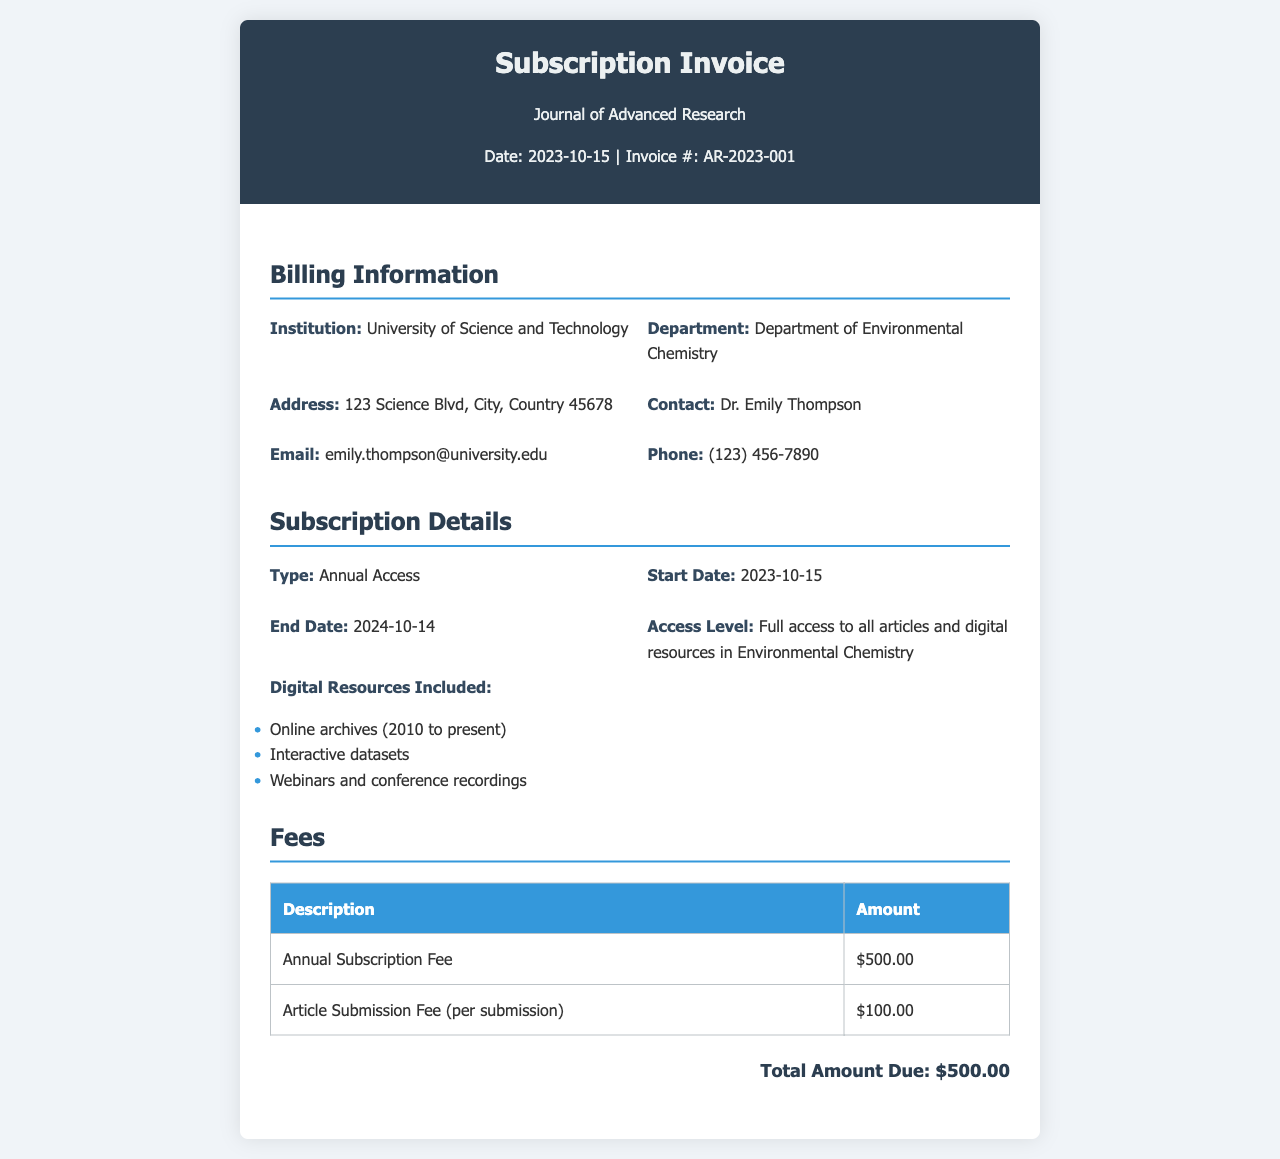What is the invoice date? The invoice date is specified in the header section of the document.
Answer: 2023-10-15 Who is the contact person listed on the invoice? The contact person is mentioned in the billing information section.
Answer: Dr. Emily Thompson What is the total amount due for the subscription? The total amount due is shown at the bottom of the fees section.
Answer: $500.00 What is the subscription type? The type of subscription is described in the subscription details section.
Answer: Annual Access What digital resources are included in the subscription? The included digital resources are listed in the subscription details section.
Answer: Online archives (2010 to present), Interactive datasets, Webinars and conference recordings What is the start date of the subscription? The start date is specified in the subscription details section.
Answer: 2023-10-15 How much is the article submission fee? The article submission fee can be found in the fees table.
Answer: $100.00 What is the access level provided by the subscription? The access level is detailed in the subscription details section.
Answer: Full access to all articles and digital resources in Environmental Chemistry 